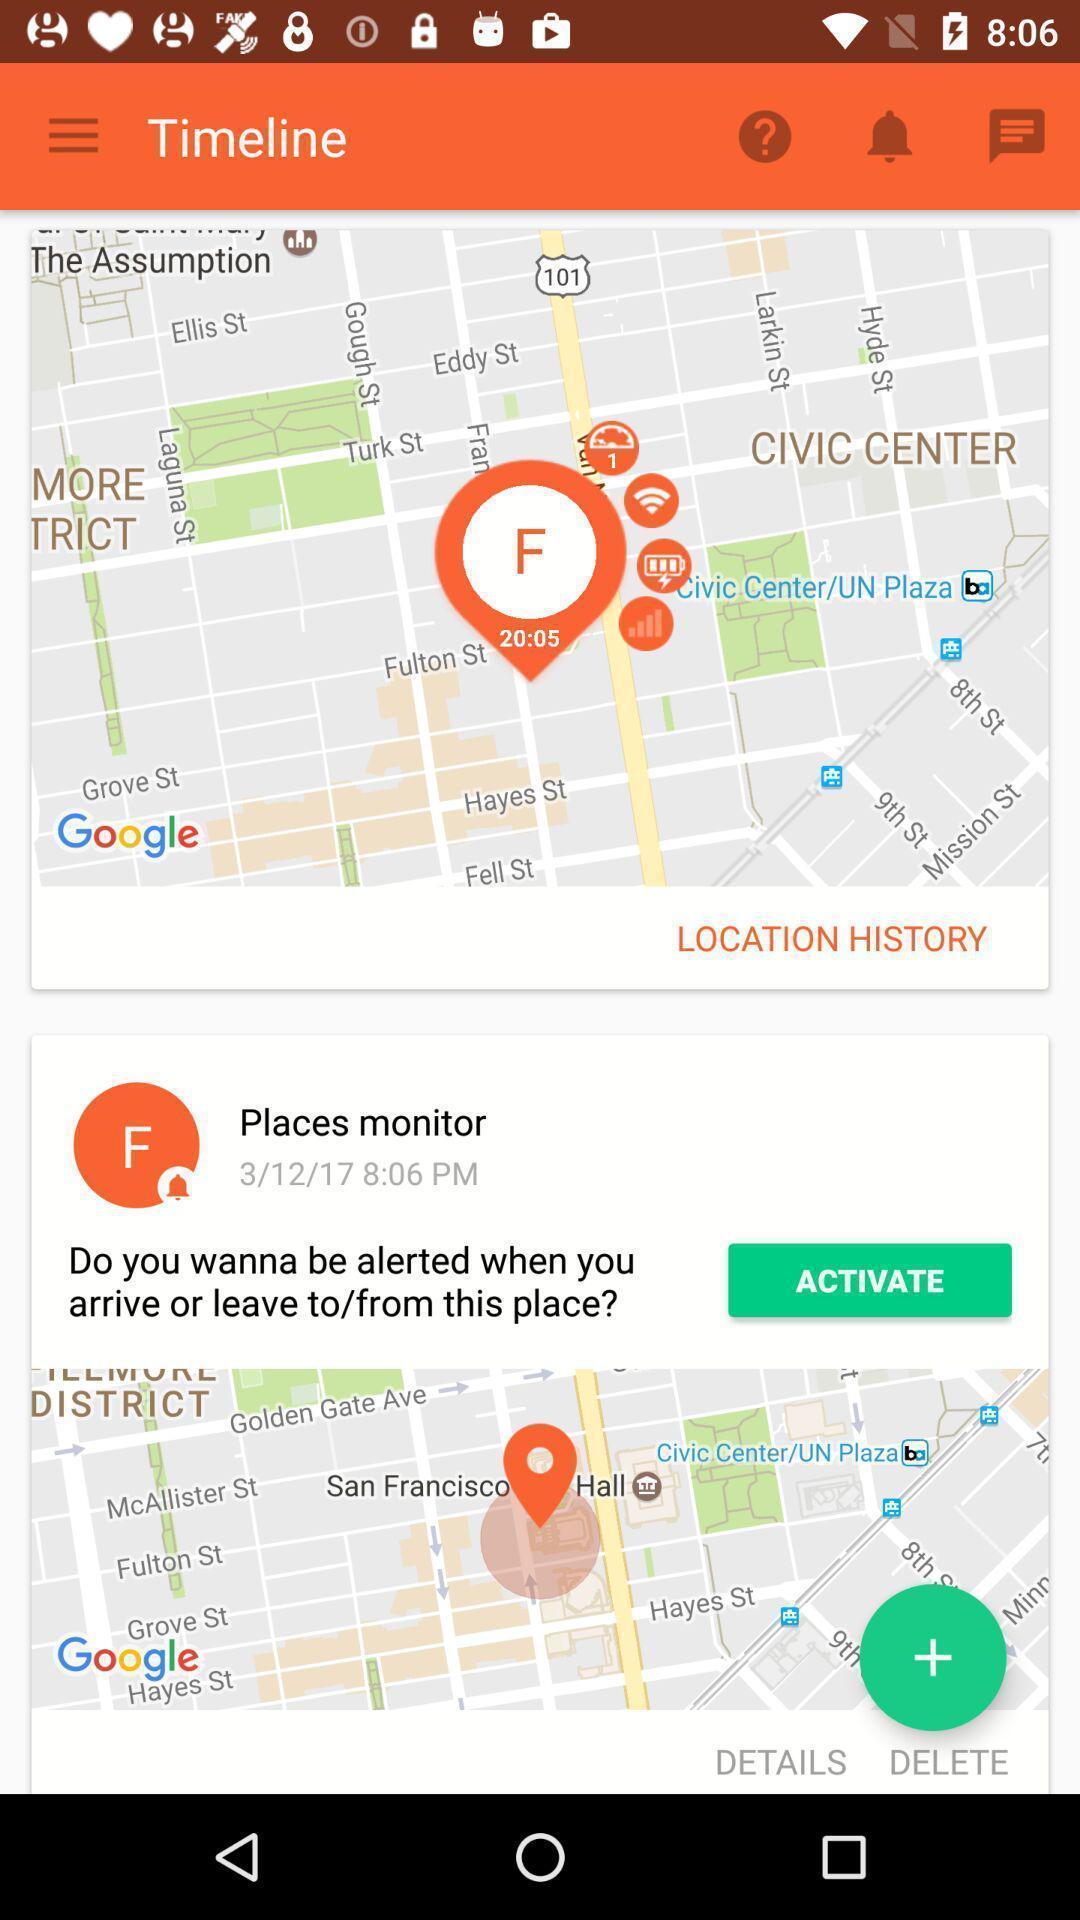Provide a description of this screenshot. Screen displaying the timeline page. 